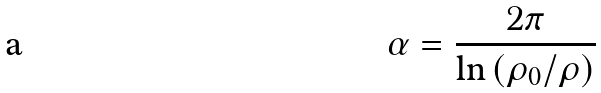<formula> <loc_0><loc_0><loc_500><loc_500>\alpha = \frac { 2 \pi } { \ln \left ( \rho _ { 0 } / \rho \right ) }</formula> 